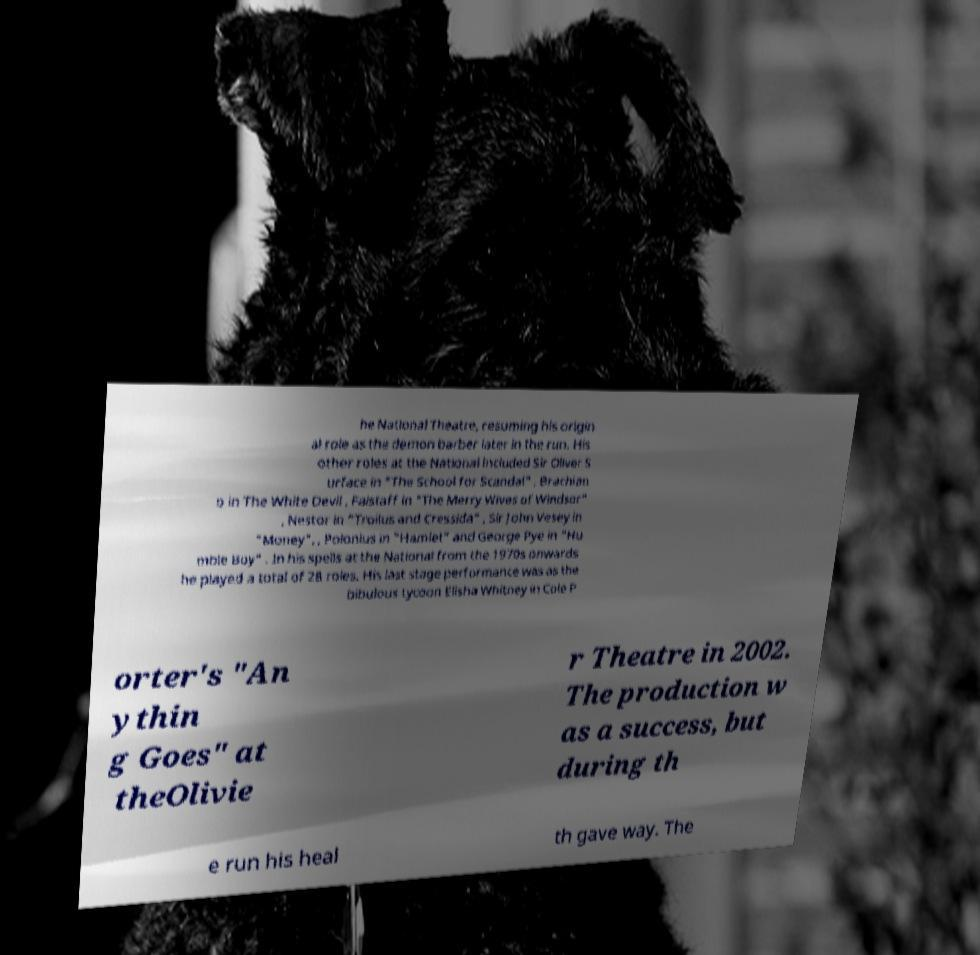For documentation purposes, I need the text within this image transcribed. Could you provide that? he National Theatre, resuming his origin al role as the demon barber later in the run. His other roles at the National included Sir Oliver S urface in "The School for Scandal" , Brachian o in The White Devil , Falstaff in "The Merry Wives of Windsor" , Nestor in "Troilus and Cressida" , Sir John Vesey in "Money", , Polonius in "Hamlet" and George Pye in "Hu mble Boy" . In his spells at the National from the 1970s onwards he played a total of 28 roles. His last stage performance was as the bibulous tycoon Elisha Whitney in Cole P orter's "An ythin g Goes" at theOlivie r Theatre in 2002. The production w as a success, but during th e run his heal th gave way. The 